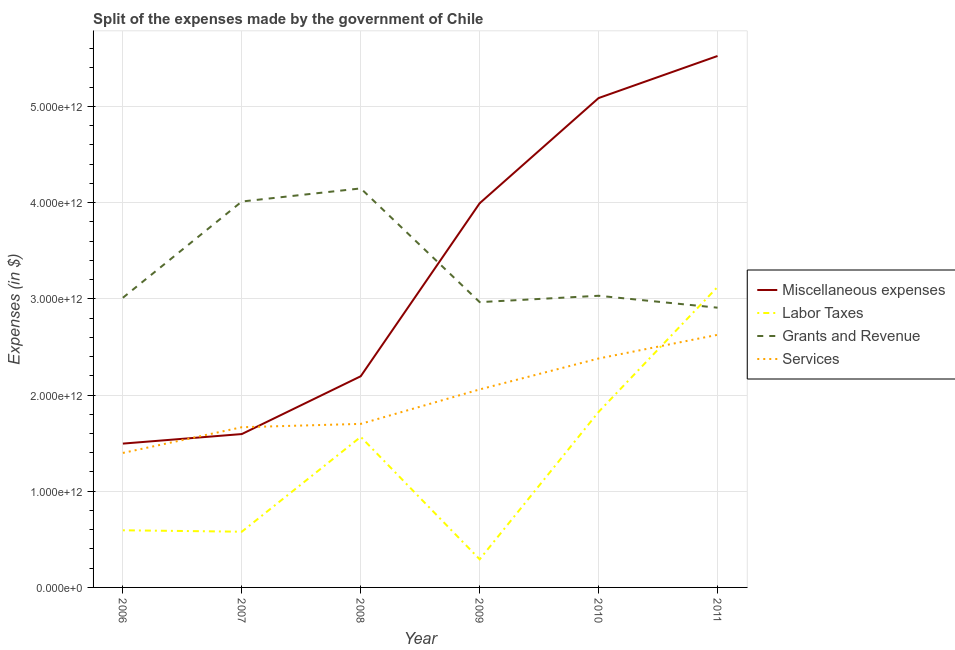Does the line corresponding to amount spent on miscellaneous expenses intersect with the line corresponding to amount spent on labor taxes?
Make the answer very short. No. What is the amount spent on miscellaneous expenses in 2007?
Give a very brief answer. 1.59e+12. Across all years, what is the maximum amount spent on services?
Provide a succinct answer. 2.63e+12. Across all years, what is the minimum amount spent on miscellaneous expenses?
Ensure brevity in your answer.  1.50e+12. In which year was the amount spent on miscellaneous expenses maximum?
Your answer should be very brief. 2011. In which year was the amount spent on grants and revenue minimum?
Ensure brevity in your answer.  2011. What is the total amount spent on grants and revenue in the graph?
Ensure brevity in your answer.  2.01e+13. What is the difference between the amount spent on miscellaneous expenses in 2009 and that in 2010?
Make the answer very short. -1.09e+12. What is the difference between the amount spent on miscellaneous expenses in 2009 and the amount spent on services in 2006?
Provide a succinct answer. 2.60e+12. What is the average amount spent on grants and revenue per year?
Provide a succinct answer. 3.35e+12. In the year 2011, what is the difference between the amount spent on services and amount spent on miscellaneous expenses?
Offer a terse response. -2.90e+12. In how many years, is the amount spent on services greater than 3200000000000 $?
Make the answer very short. 0. What is the ratio of the amount spent on grants and revenue in 2009 to that in 2010?
Ensure brevity in your answer.  0.98. Is the difference between the amount spent on grants and revenue in 2009 and 2011 greater than the difference between the amount spent on services in 2009 and 2011?
Make the answer very short. Yes. What is the difference between the highest and the second highest amount spent on grants and revenue?
Your answer should be compact. 1.36e+11. What is the difference between the highest and the lowest amount spent on services?
Ensure brevity in your answer.  1.23e+12. Is it the case that in every year, the sum of the amount spent on services and amount spent on grants and revenue is greater than the sum of amount spent on labor taxes and amount spent on miscellaneous expenses?
Provide a short and direct response. No. Is the amount spent on grants and revenue strictly greater than the amount spent on services over the years?
Offer a very short reply. Yes. How many lines are there?
Offer a very short reply. 4. How many years are there in the graph?
Make the answer very short. 6. What is the difference between two consecutive major ticks on the Y-axis?
Offer a terse response. 1.00e+12. Does the graph contain any zero values?
Provide a succinct answer. No. Does the graph contain grids?
Keep it short and to the point. Yes. What is the title of the graph?
Offer a very short reply. Split of the expenses made by the government of Chile. What is the label or title of the Y-axis?
Keep it short and to the point. Expenses (in $). What is the Expenses (in $) in Miscellaneous expenses in 2006?
Your answer should be very brief. 1.50e+12. What is the Expenses (in $) in Labor Taxes in 2006?
Offer a very short reply. 5.94e+11. What is the Expenses (in $) of Grants and Revenue in 2006?
Make the answer very short. 3.01e+12. What is the Expenses (in $) in Services in 2006?
Offer a very short reply. 1.40e+12. What is the Expenses (in $) of Miscellaneous expenses in 2007?
Give a very brief answer. 1.59e+12. What is the Expenses (in $) of Labor Taxes in 2007?
Your answer should be very brief. 5.79e+11. What is the Expenses (in $) of Grants and Revenue in 2007?
Give a very brief answer. 4.01e+12. What is the Expenses (in $) in Services in 2007?
Give a very brief answer. 1.67e+12. What is the Expenses (in $) of Miscellaneous expenses in 2008?
Your answer should be compact. 2.20e+12. What is the Expenses (in $) in Labor Taxes in 2008?
Your answer should be compact. 1.57e+12. What is the Expenses (in $) of Grants and Revenue in 2008?
Keep it short and to the point. 4.15e+12. What is the Expenses (in $) in Services in 2008?
Give a very brief answer. 1.70e+12. What is the Expenses (in $) of Miscellaneous expenses in 2009?
Offer a very short reply. 3.99e+12. What is the Expenses (in $) in Labor Taxes in 2009?
Ensure brevity in your answer.  2.92e+11. What is the Expenses (in $) of Grants and Revenue in 2009?
Give a very brief answer. 2.97e+12. What is the Expenses (in $) in Services in 2009?
Give a very brief answer. 2.06e+12. What is the Expenses (in $) in Miscellaneous expenses in 2010?
Keep it short and to the point. 5.09e+12. What is the Expenses (in $) of Labor Taxes in 2010?
Offer a very short reply. 1.82e+12. What is the Expenses (in $) of Grants and Revenue in 2010?
Your answer should be very brief. 3.03e+12. What is the Expenses (in $) in Services in 2010?
Provide a succinct answer. 2.38e+12. What is the Expenses (in $) in Miscellaneous expenses in 2011?
Your response must be concise. 5.52e+12. What is the Expenses (in $) of Labor Taxes in 2011?
Offer a very short reply. 3.12e+12. What is the Expenses (in $) in Grants and Revenue in 2011?
Your response must be concise. 2.91e+12. What is the Expenses (in $) of Services in 2011?
Provide a succinct answer. 2.63e+12. Across all years, what is the maximum Expenses (in $) in Miscellaneous expenses?
Your answer should be very brief. 5.52e+12. Across all years, what is the maximum Expenses (in $) in Labor Taxes?
Make the answer very short. 3.12e+12. Across all years, what is the maximum Expenses (in $) in Grants and Revenue?
Provide a succinct answer. 4.15e+12. Across all years, what is the maximum Expenses (in $) of Services?
Offer a very short reply. 2.63e+12. Across all years, what is the minimum Expenses (in $) of Miscellaneous expenses?
Ensure brevity in your answer.  1.50e+12. Across all years, what is the minimum Expenses (in $) in Labor Taxes?
Provide a succinct answer. 2.92e+11. Across all years, what is the minimum Expenses (in $) in Grants and Revenue?
Your response must be concise. 2.91e+12. Across all years, what is the minimum Expenses (in $) in Services?
Your answer should be very brief. 1.40e+12. What is the total Expenses (in $) in Miscellaneous expenses in the graph?
Offer a very short reply. 1.99e+13. What is the total Expenses (in $) in Labor Taxes in the graph?
Provide a short and direct response. 7.98e+12. What is the total Expenses (in $) of Grants and Revenue in the graph?
Your answer should be very brief. 2.01e+13. What is the total Expenses (in $) in Services in the graph?
Offer a terse response. 1.18e+13. What is the difference between the Expenses (in $) in Miscellaneous expenses in 2006 and that in 2007?
Provide a succinct answer. -9.92e+1. What is the difference between the Expenses (in $) of Labor Taxes in 2006 and that in 2007?
Provide a succinct answer. 1.48e+1. What is the difference between the Expenses (in $) of Grants and Revenue in 2006 and that in 2007?
Ensure brevity in your answer.  -1.00e+12. What is the difference between the Expenses (in $) in Services in 2006 and that in 2007?
Provide a short and direct response. -2.67e+11. What is the difference between the Expenses (in $) of Miscellaneous expenses in 2006 and that in 2008?
Your answer should be compact. -7.00e+11. What is the difference between the Expenses (in $) in Labor Taxes in 2006 and that in 2008?
Keep it short and to the point. -9.71e+11. What is the difference between the Expenses (in $) in Grants and Revenue in 2006 and that in 2008?
Offer a very short reply. -1.14e+12. What is the difference between the Expenses (in $) in Services in 2006 and that in 2008?
Your answer should be very brief. -3.02e+11. What is the difference between the Expenses (in $) in Miscellaneous expenses in 2006 and that in 2009?
Make the answer very short. -2.50e+12. What is the difference between the Expenses (in $) in Labor Taxes in 2006 and that in 2009?
Offer a very short reply. 3.02e+11. What is the difference between the Expenses (in $) in Grants and Revenue in 2006 and that in 2009?
Give a very brief answer. 4.55e+1. What is the difference between the Expenses (in $) in Services in 2006 and that in 2009?
Keep it short and to the point. -6.60e+11. What is the difference between the Expenses (in $) of Miscellaneous expenses in 2006 and that in 2010?
Provide a succinct answer. -3.59e+12. What is the difference between the Expenses (in $) of Labor Taxes in 2006 and that in 2010?
Provide a short and direct response. -1.23e+12. What is the difference between the Expenses (in $) of Grants and Revenue in 2006 and that in 2010?
Give a very brief answer. -2.07e+1. What is the difference between the Expenses (in $) in Services in 2006 and that in 2010?
Offer a terse response. -9.82e+11. What is the difference between the Expenses (in $) in Miscellaneous expenses in 2006 and that in 2011?
Your answer should be compact. -4.03e+12. What is the difference between the Expenses (in $) of Labor Taxes in 2006 and that in 2011?
Provide a short and direct response. -2.53e+12. What is the difference between the Expenses (in $) in Grants and Revenue in 2006 and that in 2011?
Your response must be concise. 1.03e+11. What is the difference between the Expenses (in $) in Services in 2006 and that in 2011?
Ensure brevity in your answer.  -1.23e+12. What is the difference between the Expenses (in $) in Miscellaneous expenses in 2007 and that in 2008?
Your response must be concise. -6.01e+11. What is the difference between the Expenses (in $) in Labor Taxes in 2007 and that in 2008?
Ensure brevity in your answer.  -9.86e+11. What is the difference between the Expenses (in $) of Grants and Revenue in 2007 and that in 2008?
Provide a succinct answer. -1.36e+11. What is the difference between the Expenses (in $) of Services in 2007 and that in 2008?
Keep it short and to the point. -3.46e+1. What is the difference between the Expenses (in $) of Miscellaneous expenses in 2007 and that in 2009?
Your response must be concise. -2.40e+12. What is the difference between the Expenses (in $) in Labor Taxes in 2007 and that in 2009?
Your response must be concise. 2.87e+11. What is the difference between the Expenses (in $) of Grants and Revenue in 2007 and that in 2009?
Provide a succinct answer. 1.05e+12. What is the difference between the Expenses (in $) in Services in 2007 and that in 2009?
Provide a short and direct response. -3.93e+11. What is the difference between the Expenses (in $) in Miscellaneous expenses in 2007 and that in 2010?
Your answer should be compact. -3.49e+12. What is the difference between the Expenses (in $) of Labor Taxes in 2007 and that in 2010?
Your answer should be very brief. -1.25e+12. What is the difference between the Expenses (in $) in Grants and Revenue in 2007 and that in 2010?
Provide a short and direct response. 9.80e+11. What is the difference between the Expenses (in $) of Services in 2007 and that in 2010?
Give a very brief answer. -7.14e+11. What is the difference between the Expenses (in $) of Miscellaneous expenses in 2007 and that in 2011?
Your answer should be very brief. -3.93e+12. What is the difference between the Expenses (in $) of Labor Taxes in 2007 and that in 2011?
Your response must be concise. -2.54e+12. What is the difference between the Expenses (in $) in Grants and Revenue in 2007 and that in 2011?
Ensure brevity in your answer.  1.10e+12. What is the difference between the Expenses (in $) in Services in 2007 and that in 2011?
Offer a terse response. -9.60e+11. What is the difference between the Expenses (in $) of Miscellaneous expenses in 2008 and that in 2009?
Provide a short and direct response. -1.80e+12. What is the difference between the Expenses (in $) of Labor Taxes in 2008 and that in 2009?
Offer a terse response. 1.27e+12. What is the difference between the Expenses (in $) in Grants and Revenue in 2008 and that in 2009?
Provide a succinct answer. 1.18e+12. What is the difference between the Expenses (in $) in Services in 2008 and that in 2009?
Provide a succinct answer. -3.58e+11. What is the difference between the Expenses (in $) in Miscellaneous expenses in 2008 and that in 2010?
Offer a terse response. -2.89e+12. What is the difference between the Expenses (in $) of Labor Taxes in 2008 and that in 2010?
Make the answer very short. -2.59e+11. What is the difference between the Expenses (in $) of Grants and Revenue in 2008 and that in 2010?
Offer a terse response. 1.12e+12. What is the difference between the Expenses (in $) of Services in 2008 and that in 2010?
Your answer should be compact. -6.80e+11. What is the difference between the Expenses (in $) of Miscellaneous expenses in 2008 and that in 2011?
Offer a terse response. -3.33e+12. What is the difference between the Expenses (in $) of Labor Taxes in 2008 and that in 2011?
Your answer should be compact. -1.56e+12. What is the difference between the Expenses (in $) in Grants and Revenue in 2008 and that in 2011?
Ensure brevity in your answer.  1.24e+12. What is the difference between the Expenses (in $) in Services in 2008 and that in 2011?
Give a very brief answer. -9.26e+11. What is the difference between the Expenses (in $) of Miscellaneous expenses in 2009 and that in 2010?
Keep it short and to the point. -1.09e+12. What is the difference between the Expenses (in $) in Labor Taxes in 2009 and that in 2010?
Provide a short and direct response. -1.53e+12. What is the difference between the Expenses (in $) of Grants and Revenue in 2009 and that in 2010?
Your response must be concise. -6.61e+1. What is the difference between the Expenses (in $) in Services in 2009 and that in 2010?
Provide a short and direct response. -3.21e+11. What is the difference between the Expenses (in $) in Miscellaneous expenses in 2009 and that in 2011?
Make the answer very short. -1.53e+12. What is the difference between the Expenses (in $) in Labor Taxes in 2009 and that in 2011?
Your answer should be very brief. -2.83e+12. What is the difference between the Expenses (in $) in Grants and Revenue in 2009 and that in 2011?
Your answer should be compact. 5.78e+1. What is the difference between the Expenses (in $) in Services in 2009 and that in 2011?
Provide a succinct answer. -5.68e+11. What is the difference between the Expenses (in $) in Miscellaneous expenses in 2010 and that in 2011?
Your answer should be compact. -4.37e+11. What is the difference between the Expenses (in $) of Labor Taxes in 2010 and that in 2011?
Your answer should be very brief. -1.30e+12. What is the difference between the Expenses (in $) of Grants and Revenue in 2010 and that in 2011?
Keep it short and to the point. 1.24e+11. What is the difference between the Expenses (in $) of Services in 2010 and that in 2011?
Provide a short and direct response. -2.46e+11. What is the difference between the Expenses (in $) of Miscellaneous expenses in 2006 and the Expenses (in $) of Labor Taxes in 2007?
Your answer should be very brief. 9.16e+11. What is the difference between the Expenses (in $) of Miscellaneous expenses in 2006 and the Expenses (in $) of Grants and Revenue in 2007?
Offer a terse response. -2.52e+12. What is the difference between the Expenses (in $) of Miscellaneous expenses in 2006 and the Expenses (in $) of Services in 2007?
Offer a terse response. -1.70e+11. What is the difference between the Expenses (in $) in Labor Taxes in 2006 and the Expenses (in $) in Grants and Revenue in 2007?
Provide a short and direct response. -3.42e+12. What is the difference between the Expenses (in $) of Labor Taxes in 2006 and the Expenses (in $) of Services in 2007?
Make the answer very short. -1.07e+12. What is the difference between the Expenses (in $) of Grants and Revenue in 2006 and the Expenses (in $) of Services in 2007?
Offer a terse response. 1.35e+12. What is the difference between the Expenses (in $) of Miscellaneous expenses in 2006 and the Expenses (in $) of Labor Taxes in 2008?
Give a very brief answer. -7.01e+1. What is the difference between the Expenses (in $) of Miscellaneous expenses in 2006 and the Expenses (in $) of Grants and Revenue in 2008?
Offer a terse response. -2.65e+12. What is the difference between the Expenses (in $) in Miscellaneous expenses in 2006 and the Expenses (in $) in Services in 2008?
Offer a very short reply. -2.05e+11. What is the difference between the Expenses (in $) in Labor Taxes in 2006 and the Expenses (in $) in Grants and Revenue in 2008?
Your response must be concise. -3.55e+12. What is the difference between the Expenses (in $) of Labor Taxes in 2006 and the Expenses (in $) of Services in 2008?
Make the answer very short. -1.11e+12. What is the difference between the Expenses (in $) of Grants and Revenue in 2006 and the Expenses (in $) of Services in 2008?
Provide a short and direct response. 1.31e+12. What is the difference between the Expenses (in $) of Miscellaneous expenses in 2006 and the Expenses (in $) of Labor Taxes in 2009?
Your response must be concise. 1.20e+12. What is the difference between the Expenses (in $) of Miscellaneous expenses in 2006 and the Expenses (in $) of Grants and Revenue in 2009?
Give a very brief answer. -1.47e+12. What is the difference between the Expenses (in $) in Miscellaneous expenses in 2006 and the Expenses (in $) in Services in 2009?
Your answer should be compact. -5.63e+11. What is the difference between the Expenses (in $) in Labor Taxes in 2006 and the Expenses (in $) in Grants and Revenue in 2009?
Make the answer very short. -2.37e+12. What is the difference between the Expenses (in $) in Labor Taxes in 2006 and the Expenses (in $) in Services in 2009?
Ensure brevity in your answer.  -1.46e+12. What is the difference between the Expenses (in $) in Grants and Revenue in 2006 and the Expenses (in $) in Services in 2009?
Your answer should be compact. 9.53e+11. What is the difference between the Expenses (in $) in Miscellaneous expenses in 2006 and the Expenses (in $) in Labor Taxes in 2010?
Your answer should be compact. -3.29e+11. What is the difference between the Expenses (in $) in Miscellaneous expenses in 2006 and the Expenses (in $) in Grants and Revenue in 2010?
Provide a succinct answer. -1.54e+12. What is the difference between the Expenses (in $) of Miscellaneous expenses in 2006 and the Expenses (in $) of Services in 2010?
Your answer should be very brief. -8.85e+11. What is the difference between the Expenses (in $) of Labor Taxes in 2006 and the Expenses (in $) of Grants and Revenue in 2010?
Your response must be concise. -2.44e+12. What is the difference between the Expenses (in $) of Labor Taxes in 2006 and the Expenses (in $) of Services in 2010?
Your answer should be compact. -1.79e+12. What is the difference between the Expenses (in $) of Grants and Revenue in 2006 and the Expenses (in $) of Services in 2010?
Provide a short and direct response. 6.31e+11. What is the difference between the Expenses (in $) in Miscellaneous expenses in 2006 and the Expenses (in $) in Labor Taxes in 2011?
Provide a short and direct response. -1.63e+12. What is the difference between the Expenses (in $) of Miscellaneous expenses in 2006 and the Expenses (in $) of Grants and Revenue in 2011?
Your answer should be compact. -1.41e+12. What is the difference between the Expenses (in $) in Miscellaneous expenses in 2006 and the Expenses (in $) in Services in 2011?
Ensure brevity in your answer.  -1.13e+12. What is the difference between the Expenses (in $) in Labor Taxes in 2006 and the Expenses (in $) in Grants and Revenue in 2011?
Keep it short and to the point. -2.31e+12. What is the difference between the Expenses (in $) in Labor Taxes in 2006 and the Expenses (in $) in Services in 2011?
Keep it short and to the point. -2.03e+12. What is the difference between the Expenses (in $) of Grants and Revenue in 2006 and the Expenses (in $) of Services in 2011?
Your answer should be very brief. 3.85e+11. What is the difference between the Expenses (in $) of Miscellaneous expenses in 2007 and the Expenses (in $) of Labor Taxes in 2008?
Give a very brief answer. 2.91e+1. What is the difference between the Expenses (in $) of Miscellaneous expenses in 2007 and the Expenses (in $) of Grants and Revenue in 2008?
Your response must be concise. -2.55e+12. What is the difference between the Expenses (in $) of Miscellaneous expenses in 2007 and the Expenses (in $) of Services in 2008?
Ensure brevity in your answer.  -1.06e+11. What is the difference between the Expenses (in $) of Labor Taxes in 2007 and the Expenses (in $) of Grants and Revenue in 2008?
Keep it short and to the point. -3.57e+12. What is the difference between the Expenses (in $) in Labor Taxes in 2007 and the Expenses (in $) in Services in 2008?
Your response must be concise. -1.12e+12. What is the difference between the Expenses (in $) of Grants and Revenue in 2007 and the Expenses (in $) of Services in 2008?
Give a very brief answer. 2.31e+12. What is the difference between the Expenses (in $) in Miscellaneous expenses in 2007 and the Expenses (in $) in Labor Taxes in 2009?
Provide a short and direct response. 1.30e+12. What is the difference between the Expenses (in $) in Miscellaneous expenses in 2007 and the Expenses (in $) in Grants and Revenue in 2009?
Offer a terse response. -1.37e+12. What is the difference between the Expenses (in $) in Miscellaneous expenses in 2007 and the Expenses (in $) in Services in 2009?
Your response must be concise. -4.64e+11. What is the difference between the Expenses (in $) in Labor Taxes in 2007 and the Expenses (in $) in Grants and Revenue in 2009?
Offer a terse response. -2.39e+12. What is the difference between the Expenses (in $) of Labor Taxes in 2007 and the Expenses (in $) of Services in 2009?
Ensure brevity in your answer.  -1.48e+12. What is the difference between the Expenses (in $) in Grants and Revenue in 2007 and the Expenses (in $) in Services in 2009?
Provide a succinct answer. 1.95e+12. What is the difference between the Expenses (in $) in Miscellaneous expenses in 2007 and the Expenses (in $) in Labor Taxes in 2010?
Offer a terse response. -2.30e+11. What is the difference between the Expenses (in $) in Miscellaneous expenses in 2007 and the Expenses (in $) in Grants and Revenue in 2010?
Offer a very short reply. -1.44e+12. What is the difference between the Expenses (in $) of Miscellaneous expenses in 2007 and the Expenses (in $) of Services in 2010?
Your answer should be very brief. -7.85e+11. What is the difference between the Expenses (in $) in Labor Taxes in 2007 and the Expenses (in $) in Grants and Revenue in 2010?
Offer a terse response. -2.45e+12. What is the difference between the Expenses (in $) of Labor Taxes in 2007 and the Expenses (in $) of Services in 2010?
Keep it short and to the point. -1.80e+12. What is the difference between the Expenses (in $) in Grants and Revenue in 2007 and the Expenses (in $) in Services in 2010?
Provide a succinct answer. 1.63e+12. What is the difference between the Expenses (in $) in Miscellaneous expenses in 2007 and the Expenses (in $) in Labor Taxes in 2011?
Your answer should be very brief. -1.53e+12. What is the difference between the Expenses (in $) in Miscellaneous expenses in 2007 and the Expenses (in $) in Grants and Revenue in 2011?
Provide a succinct answer. -1.31e+12. What is the difference between the Expenses (in $) of Miscellaneous expenses in 2007 and the Expenses (in $) of Services in 2011?
Offer a very short reply. -1.03e+12. What is the difference between the Expenses (in $) of Labor Taxes in 2007 and the Expenses (in $) of Grants and Revenue in 2011?
Keep it short and to the point. -2.33e+12. What is the difference between the Expenses (in $) in Labor Taxes in 2007 and the Expenses (in $) in Services in 2011?
Give a very brief answer. -2.05e+12. What is the difference between the Expenses (in $) of Grants and Revenue in 2007 and the Expenses (in $) of Services in 2011?
Your response must be concise. 1.39e+12. What is the difference between the Expenses (in $) of Miscellaneous expenses in 2008 and the Expenses (in $) of Labor Taxes in 2009?
Ensure brevity in your answer.  1.90e+12. What is the difference between the Expenses (in $) in Miscellaneous expenses in 2008 and the Expenses (in $) in Grants and Revenue in 2009?
Provide a short and direct response. -7.70e+11. What is the difference between the Expenses (in $) of Miscellaneous expenses in 2008 and the Expenses (in $) of Services in 2009?
Provide a succinct answer. 1.37e+11. What is the difference between the Expenses (in $) of Labor Taxes in 2008 and the Expenses (in $) of Grants and Revenue in 2009?
Offer a very short reply. -1.40e+12. What is the difference between the Expenses (in $) in Labor Taxes in 2008 and the Expenses (in $) in Services in 2009?
Make the answer very short. -4.93e+11. What is the difference between the Expenses (in $) of Grants and Revenue in 2008 and the Expenses (in $) of Services in 2009?
Provide a succinct answer. 2.09e+12. What is the difference between the Expenses (in $) in Miscellaneous expenses in 2008 and the Expenses (in $) in Labor Taxes in 2010?
Make the answer very short. 3.71e+11. What is the difference between the Expenses (in $) in Miscellaneous expenses in 2008 and the Expenses (in $) in Grants and Revenue in 2010?
Provide a short and direct response. -8.36e+11. What is the difference between the Expenses (in $) in Miscellaneous expenses in 2008 and the Expenses (in $) in Services in 2010?
Provide a succinct answer. -1.84e+11. What is the difference between the Expenses (in $) in Labor Taxes in 2008 and the Expenses (in $) in Grants and Revenue in 2010?
Your answer should be compact. -1.47e+12. What is the difference between the Expenses (in $) in Labor Taxes in 2008 and the Expenses (in $) in Services in 2010?
Offer a very short reply. -8.15e+11. What is the difference between the Expenses (in $) in Grants and Revenue in 2008 and the Expenses (in $) in Services in 2010?
Ensure brevity in your answer.  1.77e+12. What is the difference between the Expenses (in $) in Miscellaneous expenses in 2008 and the Expenses (in $) in Labor Taxes in 2011?
Make the answer very short. -9.28e+11. What is the difference between the Expenses (in $) in Miscellaneous expenses in 2008 and the Expenses (in $) in Grants and Revenue in 2011?
Ensure brevity in your answer.  -7.13e+11. What is the difference between the Expenses (in $) in Miscellaneous expenses in 2008 and the Expenses (in $) in Services in 2011?
Make the answer very short. -4.31e+11. What is the difference between the Expenses (in $) in Labor Taxes in 2008 and the Expenses (in $) in Grants and Revenue in 2011?
Keep it short and to the point. -1.34e+12. What is the difference between the Expenses (in $) in Labor Taxes in 2008 and the Expenses (in $) in Services in 2011?
Your response must be concise. -1.06e+12. What is the difference between the Expenses (in $) in Grants and Revenue in 2008 and the Expenses (in $) in Services in 2011?
Make the answer very short. 1.52e+12. What is the difference between the Expenses (in $) in Miscellaneous expenses in 2009 and the Expenses (in $) in Labor Taxes in 2010?
Keep it short and to the point. 2.17e+12. What is the difference between the Expenses (in $) in Miscellaneous expenses in 2009 and the Expenses (in $) in Grants and Revenue in 2010?
Your answer should be very brief. 9.62e+11. What is the difference between the Expenses (in $) in Miscellaneous expenses in 2009 and the Expenses (in $) in Services in 2010?
Make the answer very short. 1.61e+12. What is the difference between the Expenses (in $) in Labor Taxes in 2009 and the Expenses (in $) in Grants and Revenue in 2010?
Your answer should be very brief. -2.74e+12. What is the difference between the Expenses (in $) in Labor Taxes in 2009 and the Expenses (in $) in Services in 2010?
Your response must be concise. -2.09e+12. What is the difference between the Expenses (in $) in Grants and Revenue in 2009 and the Expenses (in $) in Services in 2010?
Your answer should be very brief. 5.86e+11. What is the difference between the Expenses (in $) of Miscellaneous expenses in 2009 and the Expenses (in $) of Labor Taxes in 2011?
Give a very brief answer. 8.71e+11. What is the difference between the Expenses (in $) in Miscellaneous expenses in 2009 and the Expenses (in $) in Grants and Revenue in 2011?
Give a very brief answer. 1.09e+12. What is the difference between the Expenses (in $) in Miscellaneous expenses in 2009 and the Expenses (in $) in Services in 2011?
Provide a succinct answer. 1.37e+12. What is the difference between the Expenses (in $) in Labor Taxes in 2009 and the Expenses (in $) in Grants and Revenue in 2011?
Your answer should be very brief. -2.62e+12. What is the difference between the Expenses (in $) of Labor Taxes in 2009 and the Expenses (in $) of Services in 2011?
Make the answer very short. -2.33e+12. What is the difference between the Expenses (in $) in Grants and Revenue in 2009 and the Expenses (in $) in Services in 2011?
Provide a short and direct response. 3.40e+11. What is the difference between the Expenses (in $) in Miscellaneous expenses in 2010 and the Expenses (in $) in Labor Taxes in 2011?
Provide a short and direct response. 1.96e+12. What is the difference between the Expenses (in $) of Miscellaneous expenses in 2010 and the Expenses (in $) of Grants and Revenue in 2011?
Provide a short and direct response. 2.18e+12. What is the difference between the Expenses (in $) of Miscellaneous expenses in 2010 and the Expenses (in $) of Services in 2011?
Provide a succinct answer. 2.46e+12. What is the difference between the Expenses (in $) in Labor Taxes in 2010 and the Expenses (in $) in Grants and Revenue in 2011?
Offer a very short reply. -1.08e+12. What is the difference between the Expenses (in $) in Labor Taxes in 2010 and the Expenses (in $) in Services in 2011?
Offer a terse response. -8.01e+11. What is the difference between the Expenses (in $) of Grants and Revenue in 2010 and the Expenses (in $) of Services in 2011?
Give a very brief answer. 4.06e+11. What is the average Expenses (in $) of Miscellaneous expenses per year?
Make the answer very short. 3.31e+12. What is the average Expenses (in $) of Labor Taxes per year?
Offer a very short reply. 1.33e+12. What is the average Expenses (in $) of Grants and Revenue per year?
Make the answer very short. 3.35e+12. What is the average Expenses (in $) of Services per year?
Provide a short and direct response. 1.97e+12. In the year 2006, what is the difference between the Expenses (in $) of Miscellaneous expenses and Expenses (in $) of Labor Taxes?
Your answer should be compact. 9.01e+11. In the year 2006, what is the difference between the Expenses (in $) in Miscellaneous expenses and Expenses (in $) in Grants and Revenue?
Keep it short and to the point. -1.52e+12. In the year 2006, what is the difference between the Expenses (in $) of Miscellaneous expenses and Expenses (in $) of Services?
Offer a very short reply. 9.70e+1. In the year 2006, what is the difference between the Expenses (in $) of Labor Taxes and Expenses (in $) of Grants and Revenue?
Keep it short and to the point. -2.42e+12. In the year 2006, what is the difference between the Expenses (in $) of Labor Taxes and Expenses (in $) of Services?
Offer a very short reply. -8.04e+11. In the year 2006, what is the difference between the Expenses (in $) in Grants and Revenue and Expenses (in $) in Services?
Your answer should be very brief. 1.61e+12. In the year 2007, what is the difference between the Expenses (in $) of Miscellaneous expenses and Expenses (in $) of Labor Taxes?
Provide a short and direct response. 1.02e+12. In the year 2007, what is the difference between the Expenses (in $) of Miscellaneous expenses and Expenses (in $) of Grants and Revenue?
Your answer should be very brief. -2.42e+12. In the year 2007, what is the difference between the Expenses (in $) in Miscellaneous expenses and Expenses (in $) in Services?
Your response must be concise. -7.11e+1. In the year 2007, what is the difference between the Expenses (in $) of Labor Taxes and Expenses (in $) of Grants and Revenue?
Ensure brevity in your answer.  -3.43e+12. In the year 2007, what is the difference between the Expenses (in $) of Labor Taxes and Expenses (in $) of Services?
Your answer should be very brief. -1.09e+12. In the year 2007, what is the difference between the Expenses (in $) of Grants and Revenue and Expenses (in $) of Services?
Offer a terse response. 2.35e+12. In the year 2008, what is the difference between the Expenses (in $) of Miscellaneous expenses and Expenses (in $) of Labor Taxes?
Your answer should be compact. 6.30e+11. In the year 2008, what is the difference between the Expenses (in $) of Miscellaneous expenses and Expenses (in $) of Grants and Revenue?
Your answer should be very brief. -1.95e+12. In the year 2008, what is the difference between the Expenses (in $) of Miscellaneous expenses and Expenses (in $) of Services?
Your answer should be very brief. 4.95e+11. In the year 2008, what is the difference between the Expenses (in $) of Labor Taxes and Expenses (in $) of Grants and Revenue?
Ensure brevity in your answer.  -2.58e+12. In the year 2008, what is the difference between the Expenses (in $) of Labor Taxes and Expenses (in $) of Services?
Offer a terse response. -1.35e+11. In the year 2008, what is the difference between the Expenses (in $) in Grants and Revenue and Expenses (in $) in Services?
Your response must be concise. 2.45e+12. In the year 2009, what is the difference between the Expenses (in $) in Miscellaneous expenses and Expenses (in $) in Labor Taxes?
Give a very brief answer. 3.70e+12. In the year 2009, what is the difference between the Expenses (in $) of Miscellaneous expenses and Expenses (in $) of Grants and Revenue?
Offer a very short reply. 1.03e+12. In the year 2009, what is the difference between the Expenses (in $) in Miscellaneous expenses and Expenses (in $) in Services?
Ensure brevity in your answer.  1.94e+12. In the year 2009, what is the difference between the Expenses (in $) in Labor Taxes and Expenses (in $) in Grants and Revenue?
Your answer should be compact. -2.67e+12. In the year 2009, what is the difference between the Expenses (in $) in Labor Taxes and Expenses (in $) in Services?
Your answer should be compact. -1.77e+12. In the year 2009, what is the difference between the Expenses (in $) in Grants and Revenue and Expenses (in $) in Services?
Offer a terse response. 9.07e+11. In the year 2010, what is the difference between the Expenses (in $) of Miscellaneous expenses and Expenses (in $) of Labor Taxes?
Give a very brief answer. 3.26e+12. In the year 2010, what is the difference between the Expenses (in $) in Miscellaneous expenses and Expenses (in $) in Grants and Revenue?
Provide a succinct answer. 2.06e+12. In the year 2010, what is the difference between the Expenses (in $) of Miscellaneous expenses and Expenses (in $) of Services?
Your answer should be compact. 2.71e+12. In the year 2010, what is the difference between the Expenses (in $) of Labor Taxes and Expenses (in $) of Grants and Revenue?
Your answer should be compact. -1.21e+12. In the year 2010, what is the difference between the Expenses (in $) of Labor Taxes and Expenses (in $) of Services?
Give a very brief answer. -5.55e+11. In the year 2010, what is the difference between the Expenses (in $) of Grants and Revenue and Expenses (in $) of Services?
Offer a very short reply. 6.52e+11. In the year 2011, what is the difference between the Expenses (in $) of Miscellaneous expenses and Expenses (in $) of Labor Taxes?
Your response must be concise. 2.40e+12. In the year 2011, what is the difference between the Expenses (in $) of Miscellaneous expenses and Expenses (in $) of Grants and Revenue?
Offer a very short reply. 2.62e+12. In the year 2011, what is the difference between the Expenses (in $) in Miscellaneous expenses and Expenses (in $) in Services?
Your answer should be very brief. 2.90e+12. In the year 2011, what is the difference between the Expenses (in $) in Labor Taxes and Expenses (in $) in Grants and Revenue?
Provide a short and direct response. 2.15e+11. In the year 2011, what is the difference between the Expenses (in $) in Labor Taxes and Expenses (in $) in Services?
Provide a succinct answer. 4.97e+11. In the year 2011, what is the difference between the Expenses (in $) of Grants and Revenue and Expenses (in $) of Services?
Keep it short and to the point. 2.82e+11. What is the ratio of the Expenses (in $) in Miscellaneous expenses in 2006 to that in 2007?
Keep it short and to the point. 0.94. What is the ratio of the Expenses (in $) in Labor Taxes in 2006 to that in 2007?
Offer a very short reply. 1.03. What is the ratio of the Expenses (in $) of Grants and Revenue in 2006 to that in 2007?
Provide a short and direct response. 0.75. What is the ratio of the Expenses (in $) of Services in 2006 to that in 2007?
Provide a short and direct response. 0.84. What is the ratio of the Expenses (in $) in Miscellaneous expenses in 2006 to that in 2008?
Provide a short and direct response. 0.68. What is the ratio of the Expenses (in $) of Labor Taxes in 2006 to that in 2008?
Offer a terse response. 0.38. What is the ratio of the Expenses (in $) of Grants and Revenue in 2006 to that in 2008?
Your response must be concise. 0.73. What is the ratio of the Expenses (in $) in Services in 2006 to that in 2008?
Provide a succinct answer. 0.82. What is the ratio of the Expenses (in $) in Miscellaneous expenses in 2006 to that in 2009?
Ensure brevity in your answer.  0.37. What is the ratio of the Expenses (in $) of Labor Taxes in 2006 to that in 2009?
Ensure brevity in your answer.  2.03. What is the ratio of the Expenses (in $) of Grants and Revenue in 2006 to that in 2009?
Give a very brief answer. 1.02. What is the ratio of the Expenses (in $) of Services in 2006 to that in 2009?
Offer a very short reply. 0.68. What is the ratio of the Expenses (in $) in Miscellaneous expenses in 2006 to that in 2010?
Offer a very short reply. 0.29. What is the ratio of the Expenses (in $) in Labor Taxes in 2006 to that in 2010?
Your answer should be very brief. 0.33. What is the ratio of the Expenses (in $) in Grants and Revenue in 2006 to that in 2010?
Give a very brief answer. 0.99. What is the ratio of the Expenses (in $) in Services in 2006 to that in 2010?
Ensure brevity in your answer.  0.59. What is the ratio of the Expenses (in $) of Miscellaneous expenses in 2006 to that in 2011?
Provide a short and direct response. 0.27. What is the ratio of the Expenses (in $) in Labor Taxes in 2006 to that in 2011?
Offer a terse response. 0.19. What is the ratio of the Expenses (in $) in Grants and Revenue in 2006 to that in 2011?
Offer a terse response. 1.04. What is the ratio of the Expenses (in $) of Services in 2006 to that in 2011?
Give a very brief answer. 0.53. What is the ratio of the Expenses (in $) in Miscellaneous expenses in 2007 to that in 2008?
Your answer should be compact. 0.73. What is the ratio of the Expenses (in $) in Labor Taxes in 2007 to that in 2008?
Your answer should be very brief. 0.37. What is the ratio of the Expenses (in $) of Grants and Revenue in 2007 to that in 2008?
Your answer should be compact. 0.97. What is the ratio of the Expenses (in $) of Services in 2007 to that in 2008?
Your answer should be very brief. 0.98. What is the ratio of the Expenses (in $) in Miscellaneous expenses in 2007 to that in 2009?
Ensure brevity in your answer.  0.4. What is the ratio of the Expenses (in $) in Labor Taxes in 2007 to that in 2009?
Provide a short and direct response. 1.98. What is the ratio of the Expenses (in $) of Grants and Revenue in 2007 to that in 2009?
Your answer should be very brief. 1.35. What is the ratio of the Expenses (in $) in Services in 2007 to that in 2009?
Your response must be concise. 0.81. What is the ratio of the Expenses (in $) of Miscellaneous expenses in 2007 to that in 2010?
Your answer should be very brief. 0.31. What is the ratio of the Expenses (in $) in Labor Taxes in 2007 to that in 2010?
Your response must be concise. 0.32. What is the ratio of the Expenses (in $) of Grants and Revenue in 2007 to that in 2010?
Ensure brevity in your answer.  1.32. What is the ratio of the Expenses (in $) of Services in 2007 to that in 2010?
Offer a very short reply. 0.7. What is the ratio of the Expenses (in $) in Miscellaneous expenses in 2007 to that in 2011?
Make the answer very short. 0.29. What is the ratio of the Expenses (in $) of Labor Taxes in 2007 to that in 2011?
Provide a short and direct response. 0.19. What is the ratio of the Expenses (in $) of Grants and Revenue in 2007 to that in 2011?
Provide a short and direct response. 1.38. What is the ratio of the Expenses (in $) in Services in 2007 to that in 2011?
Your response must be concise. 0.63. What is the ratio of the Expenses (in $) in Miscellaneous expenses in 2008 to that in 2009?
Your response must be concise. 0.55. What is the ratio of the Expenses (in $) in Labor Taxes in 2008 to that in 2009?
Offer a terse response. 5.35. What is the ratio of the Expenses (in $) in Grants and Revenue in 2008 to that in 2009?
Provide a succinct answer. 1.4. What is the ratio of the Expenses (in $) in Services in 2008 to that in 2009?
Your answer should be compact. 0.83. What is the ratio of the Expenses (in $) in Miscellaneous expenses in 2008 to that in 2010?
Make the answer very short. 0.43. What is the ratio of the Expenses (in $) of Labor Taxes in 2008 to that in 2010?
Your response must be concise. 0.86. What is the ratio of the Expenses (in $) in Grants and Revenue in 2008 to that in 2010?
Make the answer very short. 1.37. What is the ratio of the Expenses (in $) of Services in 2008 to that in 2010?
Your answer should be compact. 0.71. What is the ratio of the Expenses (in $) of Miscellaneous expenses in 2008 to that in 2011?
Make the answer very short. 0.4. What is the ratio of the Expenses (in $) of Labor Taxes in 2008 to that in 2011?
Your answer should be very brief. 0.5. What is the ratio of the Expenses (in $) in Grants and Revenue in 2008 to that in 2011?
Provide a short and direct response. 1.43. What is the ratio of the Expenses (in $) in Services in 2008 to that in 2011?
Offer a very short reply. 0.65. What is the ratio of the Expenses (in $) of Miscellaneous expenses in 2009 to that in 2010?
Make the answer very short. 0.79. What is the ratio of the Expenses (in $) of Labor Taxes in 2009 to that in 2010?
Keep it short and to the point. 0.16. What is the ratio of the Expenses (in $) of Grants and Revenue in 2009 to that in 2010?
Provide a succinct answer. 0.98. What is the ratio of the Expenses (in $) in Services in 2009 to that in 2010?
Offer a terse response. 0.86. What is the ratio of the Expenses (in $) of Miscellaneous expenses in 2009 to that in 2011?
Your response must be concise. 0.72. What is the ratio of the Expenses (in $) in Labor Taxes in 2009 to that in 2011?
Provide a short and direct response. 0.09. What is the ratio of the Expenses (in $) in Grants and Revenue in 2009 to that in 2011?
Keep it short and to the point. 1.02. What is the ratio of the Expenses (in $) in Services in 2009 to that in 2011?
Offer a terse response. 0.78. What is the ratio of the Expenses (in $) of Miscellaneous expenses in 2010 to that in 2011?
Ensure brevity in your answer.  0.92. What is the ratio of the Expenses (in $) in Labor Taxes in 2010 to that in 2011?
Keep it short and to the point. 0.58. What is the ratio of the Expenses (in $) in Grants and Revenue in 2010 to that in 2011?
Keep it short and to the point. 1.04. What is the ratio of the Expenses (in $) of Services in 2010 to that in 2011?
Offer a very short reply. 0.91. What is the difference between the highest and the second highest Expenses (in $) in Miscellaneous expenses?
Offer a very short reply. 4.37e+11. What is the difference between the highest and the second highest Expenses (in $) in Labor Taxes?
Offer a terse response. 1.30e+12. What is the difference between the highest and the second highest Expenses (in $) of Grants and Revenue?
Your answer should be compact. 1.36e+11. What is the difference between the highest and the second highest Expenses (in $) of Services?
Provide a succinct answer. 2.46e+11. What is the difference between the highest and the lowest Expenses (in $) in Miscellaneous expenses?
Offer a terse response. 4.03e+12. What is the difference between the highest and the lowest Expenses (in $) in Labor Taxes?
Make the answer very short. 2.83e+12. What is the difference between the highest and the lowest Expenses (in $) of Grants and Revenue?
Your response must be concise. 1.24e+12. What is the difference between the highest and the lowest Expenses (in $) in Services?
Your answer should be compact. 1.23e+12. 